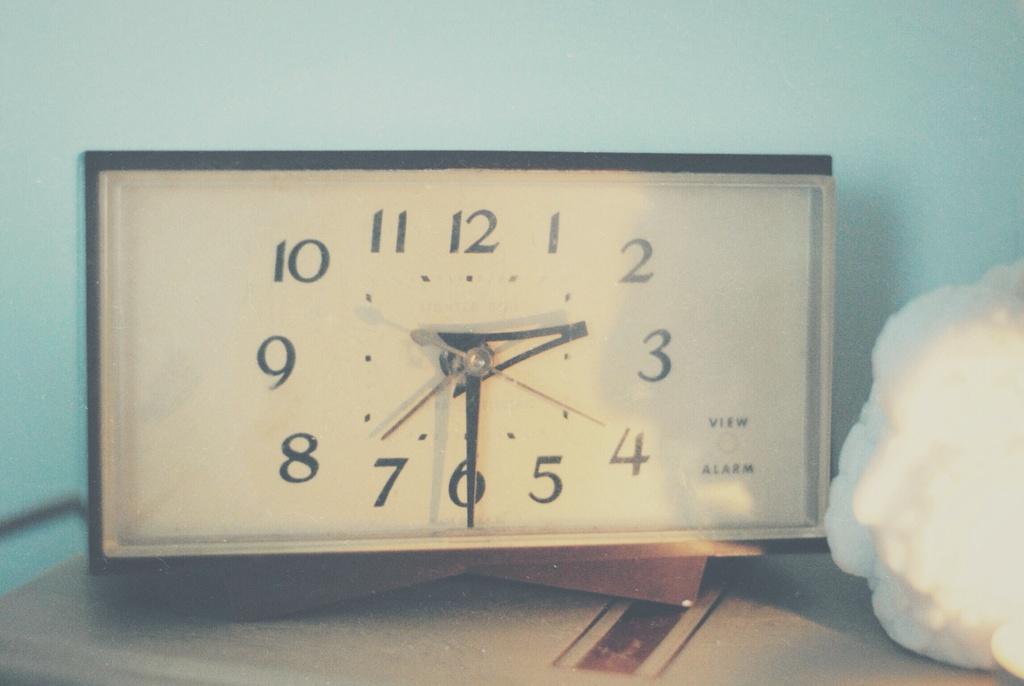What word is printed under the word "view" on the bottom right of this clock face?
Give a very brief answer. Alarm. What two words are written on the bottom right of the clock?
Make the answer very short. View alarm. 